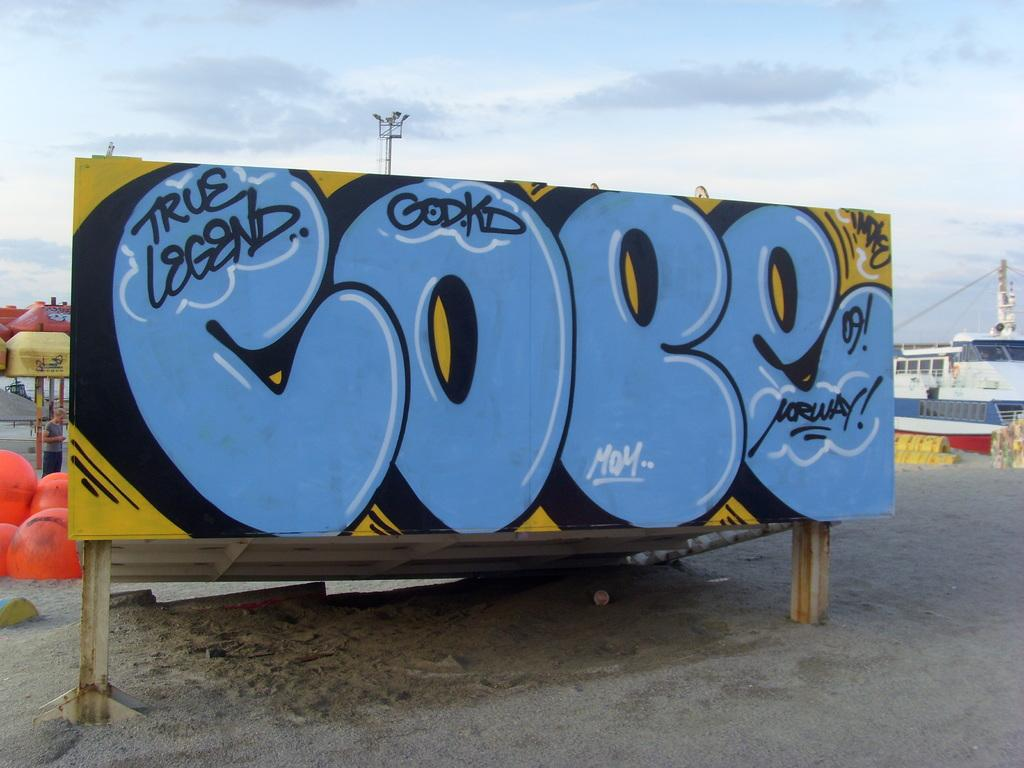<image>
Relay a brief, clear account of the picture shown. Large billboard that read COPE in graffiti on a beach. 